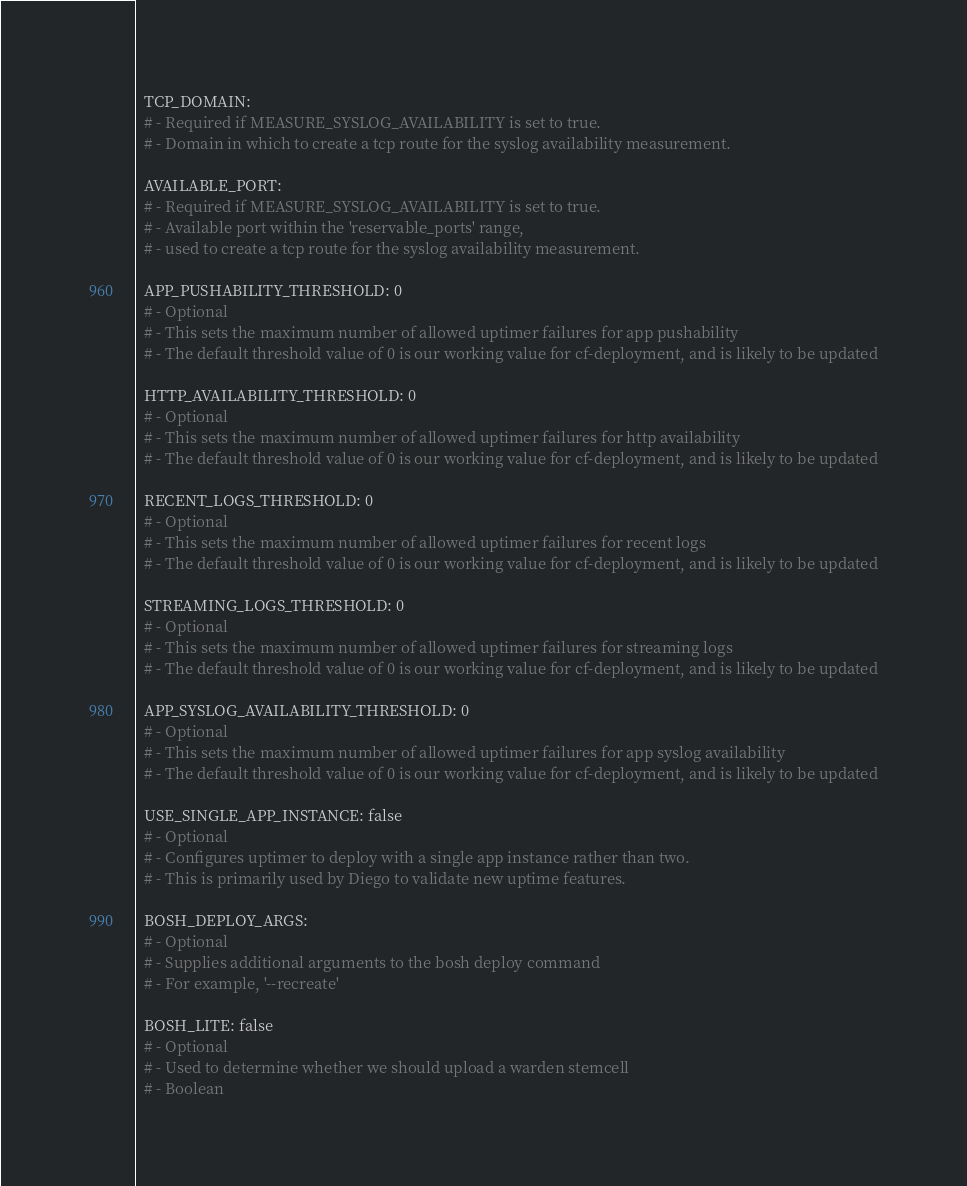Convert code to text. <code><loc_0><loc_0><loc_500><loc_500><_YAML_>
  TCP_DOMAIN:
  # - Required if MEASURE_SYSLOG_AVAILABILITY is set to true.
  # - Domain in which to create a tcp route for the syslog availability measurement.

  AVAILABLE_PORT:
  # - Required if MEASURE_SYSLOG_AVAILABILITY is set to true.
  # - Available port within the 'reservable_ports' range,
  # - used to create a tcp route for the syslog availability measurement.

  APP_PUSHABILITY_THRESHOLD: 0
  # - Optional
  # - This sets the maximum number of allowed uptimer failures for app pushability
  # - The default threshold value of 0 is our working value for cf-deployment, and is likely to be updated

  HTTP_AVAILABILITY_THRESHOLD: 0
  # - Optional
  # - This sets the maximum number of allowed uptimer failures for http availability
  # - The default threshold value of 0 is our working value for cf-deployment, and is likely to be updated

  RECENT_LOGS_THRESHOLD: 0
  # - Optional
  # - This sets the maximum number of allowed uptimer failures for recent logs
  # - The default threshold value of 0 is our working value for cf-deployment, and is likely to be updated

  STREAMING_LOGS_THRESHOLD: 0
  # - Optional
  # - This sets the maximum number of allowed uptimer failures for streaming logs
  # - The default threshold value of 0 is our working value for cf-deployment, and is likely to be updated

  APP_SYSLOG_AVAILABILITY_THRESHOLD: 0
  # - Optional
  # - This sets the maximum number of allowed uptimer failures for app syslog availability
  # - The default threshold value of 0 is our working value for cf-deployment, and is likely to be updated

  USE_SINGLE_APP_INSTANCE: false
  # - Optional
  # - Configures uptimer to deploy with a single app instance rather than two.
  # - This is primarily used by Diego to validate new uptime features.

  BOSH_DEPLOY_ARGS:
  # - Optional
  # - Supplies additional arguments to the bosh deploy command
  # - For example, '--recreate'

  BOSH_LITE: false
  # - Optional
  # - Used to determine whether we should upload a warden stemcell
  # - Boolean
</code> 